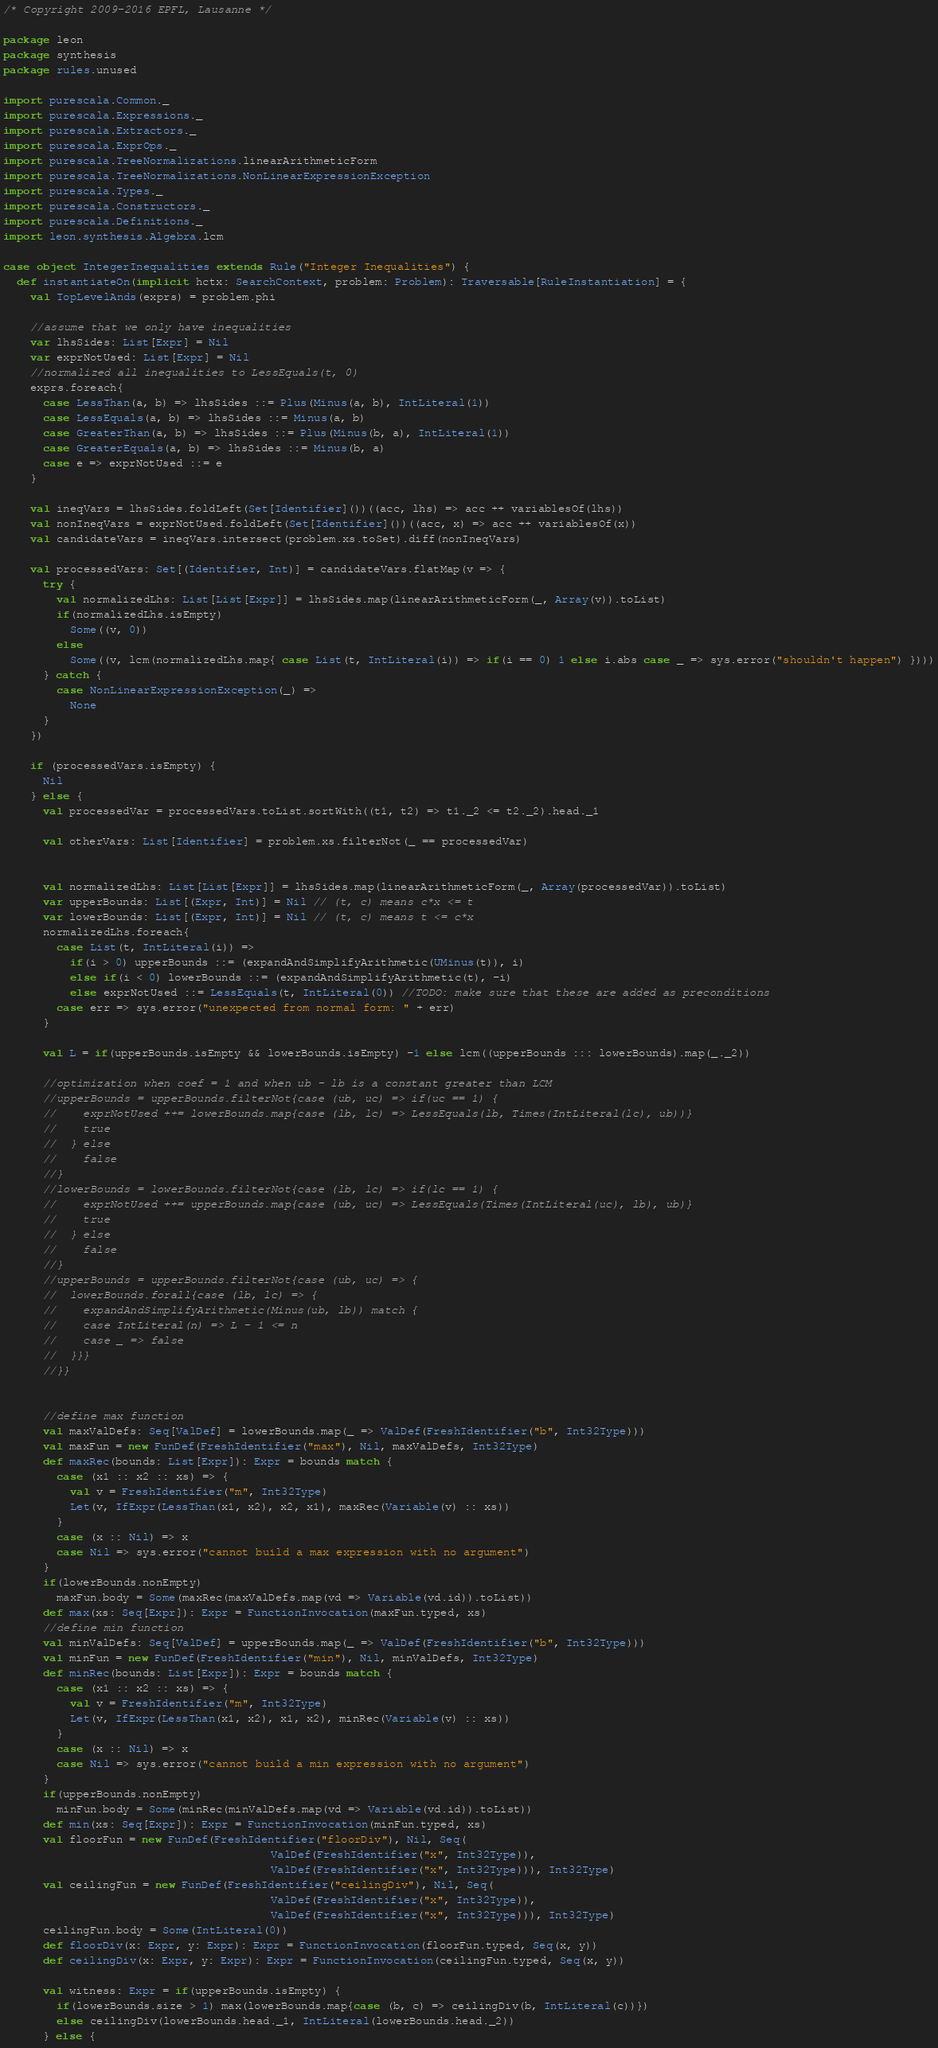Convert code to text. <code><loc_0><loc_0><loc_500><loc_500><_Scala_>/* Copyright 2009-2016 EPFL, Lausanne */

package leon
package synthesis
package rules.unused

import purescala.Common._
import purescala.Expressions._
import purescala.Extractors._
import purescala.ExprOps._
import purescala.TreeNormalizations.linearArithmeticForm
import purescala.TreeNormalizations.NonLinearExpressionException
import purescala.Types._
import purescala.Constructors._
import purescala.Definitions._
import leon.synthesis.Algebra.lcm

case object IntegerInequalities extends Rule("Integer Inequalities") {
  def instantiateOn(implicit hctx: SearchContext, problem: Problem): Traversable[RuleInstantiation] = {
    val TopLevelAnds(exprs) = problem.phi

    //assume that we only have inequalities
    var lhsSides: List[Expr] = Nil
    var exprNotUsed: List[Expr] = Nil
    //normalized all inequalities to LessEquals(t, 0)
    exprs.foreach{
      case LessThan(a, b) => lhsSides ::= Plus(Minus(a, b), IntLiteral(1))
      case LessEquals(a, b) => lhsSides ::= Minus(a, b)
      case GreaterThan(a, b) => lhsSides ::= Plus(Minus(b, a), IntLiteral(1))
      case GreaterEquals(a, b) => lhsSides ::= Minus(b, a)
      case e => exprNotUsed ::= e
    }

    val ineqVars = lhsSides.foldLeft(Set[Identifier]())((acc, lhs) => acc ++ variablesOf(lhs))
    val nonIneqVars = exprNotUsed.foldLeft(Set[Identifier]())((acc, x) => acc ++ variablesOf(x))
    val candidateVars = ineqVars.intersect(problem.xs.toSet).diff(nonIneqVars)

    val processedVars: Set[(Identifier, Int)] = candidateVars.flatMap(v => {
      try {
        val normalizedLhs: List[List[Expr]] = lhsSides.map(linearArithmeticForm(_, Array(v)).toList)
        if(normalizedLhs.isEmpty)
          Some((v, 0))
        else
          Some((v, lcm(normalizedLhs.map{ case List(t, IntLiteral(i)) => if(i == 0) 1 else i.abs case _ => sys.error("shouldn't happen") })))
      } catch {
        case NonLinearExpressionException(_) =>
          None
      }
    })

    if (processedVars.isEmpty) {
      Nil
    } else {
      val processedVar = processedVars.toList.sortWith((t1, t2) => t1._2 <= t2._2).head._1

      val otherVars: List[Identifier] = problem.xs.filterNot(_ == processedVar)


      val normalizedLhs: List[List[Expr]] = lhsSides.map(linearArithmeticForm(_, Array(processedVar)).toList)
      var upperBounds: List[(Expr, Int)] = Nil // (t, c) means c*x <= t
      var lowerBounds: List[(Expr, Int)] = Nil // (t, c) means t <= c*x
      normalizedLhs.foreach{
        case List(t, IntLiteral(i)) => 
          if(i > 0) upperBounds ::= (expandAndSimplifyArithmetic(UMinus(t)), i)
          else if(i < 0) lowerBounds ::= (expandAndSimplifyArithmetic(t), -i)
          else exprNotUsed ::= LessEquals(t, IntLiteral(0)) //TODO: make sure that these are added as preconditions
        case err => sys.error("unexpected from normal form: " + err)
      }

      val L = if(upperBounds.isEmpty && lowerBounds.isEmpty) -1 else lcm((upperBounds ::: lowerBounds).map(_._2))

      //optimization when coef = 1 and when ub - lb is a constant greater than LCM
      //upperBounds = upperBounds.filterNot{case (ub, uc) => if(uc == 1) {
      //    exprNotUsed ++= lowerBounds.map{case (lb, lc) => LessEquals(lb, Times(IntLiteral(lc), ub))}
      //    true
      //  } else
      //    false
      //}
      //lowerBounds = lowerBounds.filterNot{case (lb, lc) => if(lc == 1) {
      //    exprNotUsed ++= upperBounds.map{case (ub, uc) => LessEquals(Times(IntLiteral(uc), lb), ub)}
      //    true
      //  } else 
      //    false 
      //}
      //upperBounds = upperBounds.filterNot{case (ub, uc) => {
      //  lowerBounds.forall{case (lb, lc) => {
      //    expandAndSimplifyArithmetic(Minus(ub, lb)) match {
      //    case IntLiteral(n) => L - 1 <= n
      //    case _ => false
      //  }}}
      //}}


      //define max function
      val maxValDefs: Seq[ValDef] = lowerBounds.map(_ => ValDef(FreshIdentifier("b", Int32Type)))
      val maxFun = new FunDef(FreshIdentifier("max"), Nil, maxValDefs, Int32Type)
      def maxRec(bounds: List[Expr]): Expr = bounds match {
        case (x1 :: x2 :: xs) => {
          val v = FreshIdentifier("m", Int32Type)
          Let(v, IfExpr(LessThan(x1, x2), x2, x1), maxRec(Variable(v) :: xs))
        }
        case (x :: Nil) => x
        case Nil => sys.error("cannot build a max expression with no argument")
      }
      if(lowerBounds.nonEmpty)
        maxFun.body = Some(maxRec(maxValDefs.map(vd => Variable(vd.id)).toList))
      def max(xs: Seq[Expr]): Expr = FunctionInvocation(maxFun.typed, xs)
      //define min function
      val minValDefs: Seq[ValDef] = upperBounds.map(_ => ValDef(FreshIdentifier("b", Int32Type)))
      val minFun = new FunDef(FreshIdentifier("min"), Nil, minValDefs, Int32Type)
      def minRec(bounds: List[Expr]): Expr = bounds match {
        case (x1 :: x2 :: xs) => {
          val v = FreshIdentifier("m", Int32Type)
          Let(v, IfExpr(LessThan(x1, x2), x1, x2), minRec(Variable(v) :: xs))
        }
        case (x :: Nil) => x
        case Nil => sys.error("cannot build a min expression with no argument")
      }
      if(upperBounds.nonEmpty)
        minFun.body = Some(minRec(minValDefs.map(vd => Variable(vd.id)).toList))
      def min(xs: Seq[Expr]): Expr = FunctionInvocation(minFun.typed, xs)
      val floorFun = new FunDef(FreshIdentifier("floorDiv"), Nil, Seq(
                                        ValDef(FreshIdentifier("x", Int32Type)),
                                        ValDef(FreshIdentifier("x", Int32Type))), Int32Type)
      val ceilingFun = new FunDef(FreshIdentifier("ceilingDiv"), Nil, Seq(
                                        ValDef(FreshIdentifier("x", Int32Type)),
                                        ValDef(FreshIdentifier("x", Int32Type))), Int32Type)
      ceilingFun.body = Some(IntLiteral(0))
      def floorDiv(x: Expr, y: Expr): Expr = FunctionInvocation(floorFun.typed, Seq(x, y))
      def ceilingDiv(x: Expr, y: Expr): Expr = FunctionInvocation(ceilingFun.typed, Seq(x, y))

      val witness: Expr = if(upperBounds.isEmpty) {
        if(lowerBounds.size > 1) max(lowerBounds.map{case (b, c) => ceilingDiv(b, IntLiteral(c))})
        else ceilingDiv(lowerBounds.head._1, IntLiteral(lowerBounds.head._2))
      } else {</code> 